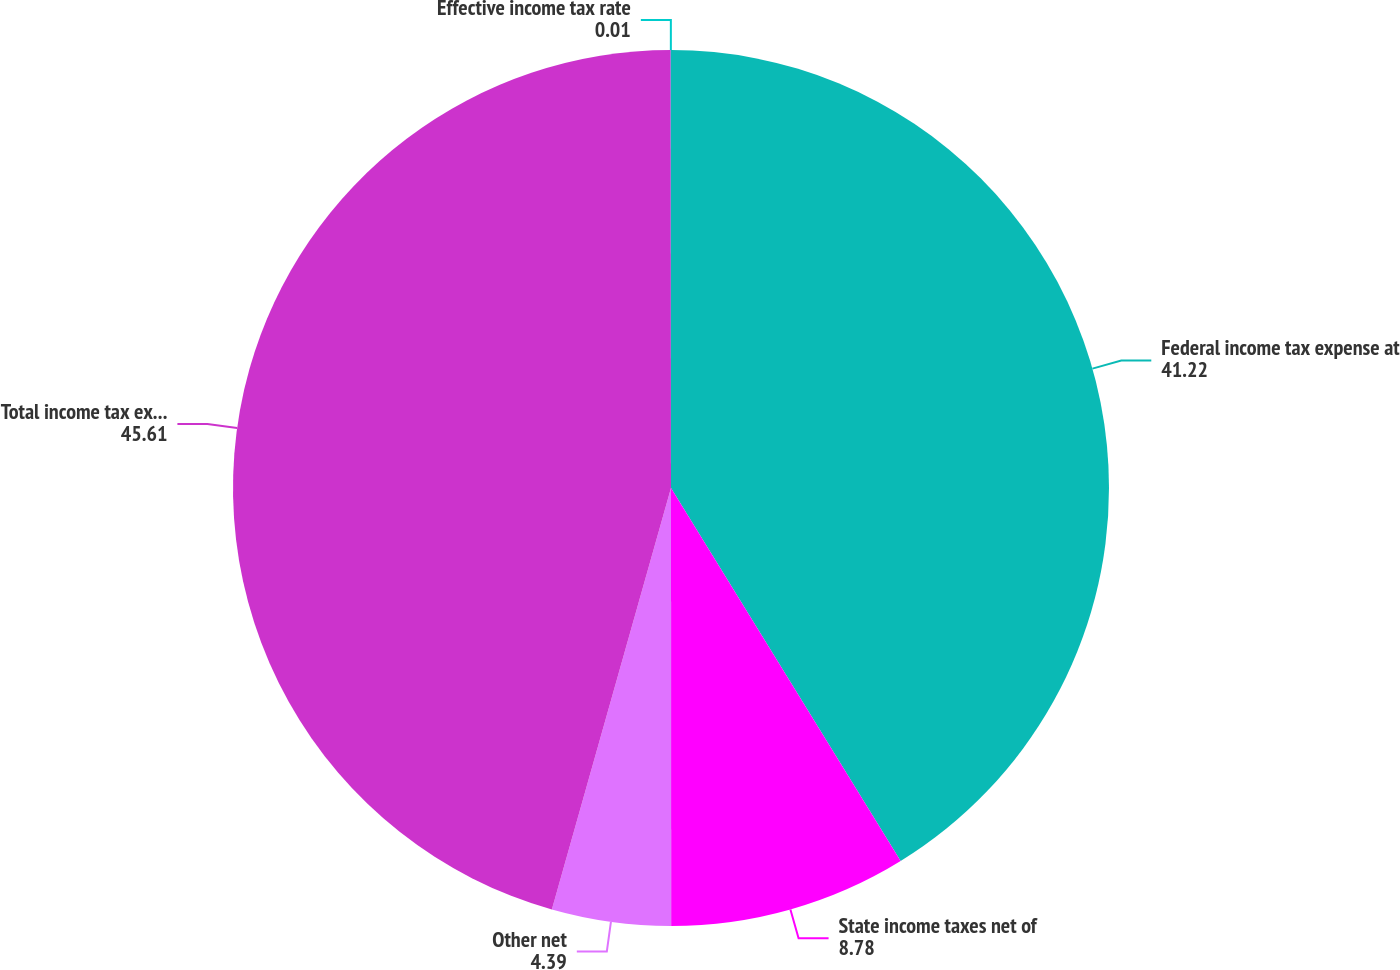Convert chart to OTSL. <chart><loc_0><loc_0><loc_500><loc_500><pie_chart><fcel>Federal income tax expense at<fcel>State income taxes net of<fcel>Other net<fcel>Total income tax expense<fcel>Effective income tax rate<nl><fcel>41.22%<fcel>8.78%<fcel>4.39%<fcel>45.61%<fcel>0.01%<nl></chart> 